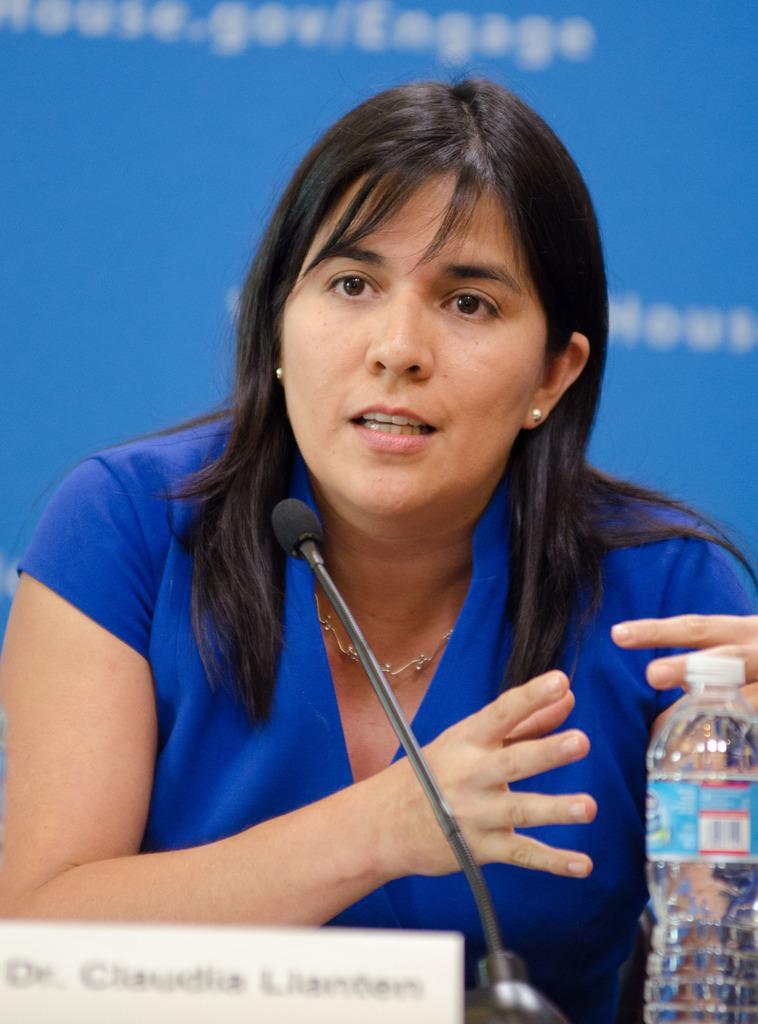Could you give a brief overview of what you see in this image? In this picture there is a woman sitting besides a table and taking on a mike. In the right side there is a water bottle. In the left bottom there is a board and some text printed on it. She is wearing a blue dress and ornament. In the background there is a wall and some text printed on it. 